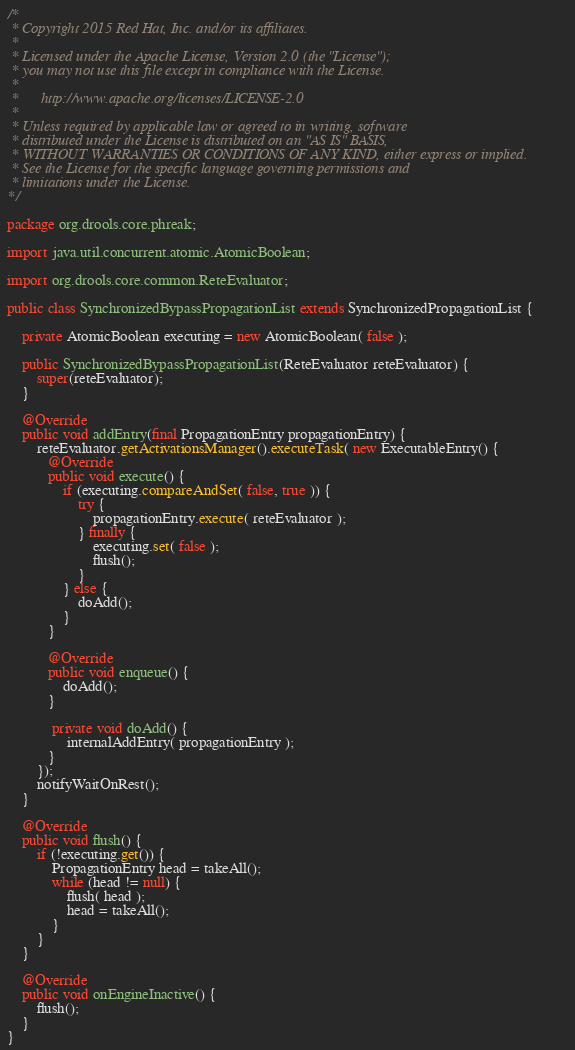<code> <loc_0><loc_0><loc_500><loc_500><_Java_>/*
 * Copyright 2015 Red Hat, Inc. and/or its affiliates.
 *
 * Licensed under the Apache License, Version 2.0 (the "License");
 * you may not use this file except in compliance with the License.
 * 
 *      http://www.apache.org/licenses/LICENSE-2.0
 *
 * Unless required by applicable law or agreed to in writing, software
 * distributed under the License is distributed on an "AS IS" BASIS,
 * WITHOUT WARRANTIES OR CONDITIONS OF ANY KIND, either express or implied.
 * See the License for the specific language governing permissions and
 * limitations under the License.
*/

package org.drools.core.phreak;

import java.util.concurrent.atomic.AtomicBoolean;

import org.drools.core.common.ReteEvaluator;

public class SynchronizedBypassPropagationList extends SynchronizedPropagationList {

    private AtomicBoolean executing = new AtomicBoolean( false );

    public SynchronizedBypassPropagationList(ReteEvaluator reteEvaluator) {
        super(reteEvaluator);
    }

    @Override
    public void addEntry(final PropagationEntry propagationEntry) {
        reteEvaluator.getActivationsManager().executeTask( new ExecutableEntry() {
           @Override
           public void execute() {
               if (executing.compareAndSet( false, true )) {
                   try {
                       propagationEntry.execute( reteEvaluator );
                   } finally {
                       executing.set( false );
                       flush();
                   }
               } else {
                   doAdd();
               }
           }

           @Override
           public void enqueue() {
               doAdd();
           }

            private void doAdd() {
                internalAddEntry( propagationEntry );
           }
        });
        notifyWaitOnRest();
    }

    @Override
    public void flush() {
        if (!executing.get()) {
            PropagationEntry head = takeAll();
            while (head != null) {
                flush( head );
                head = takeAll();
            }
        }
    }

    @Override
    public void onEngineInactive() {
        flush();
    }
}
</code> 